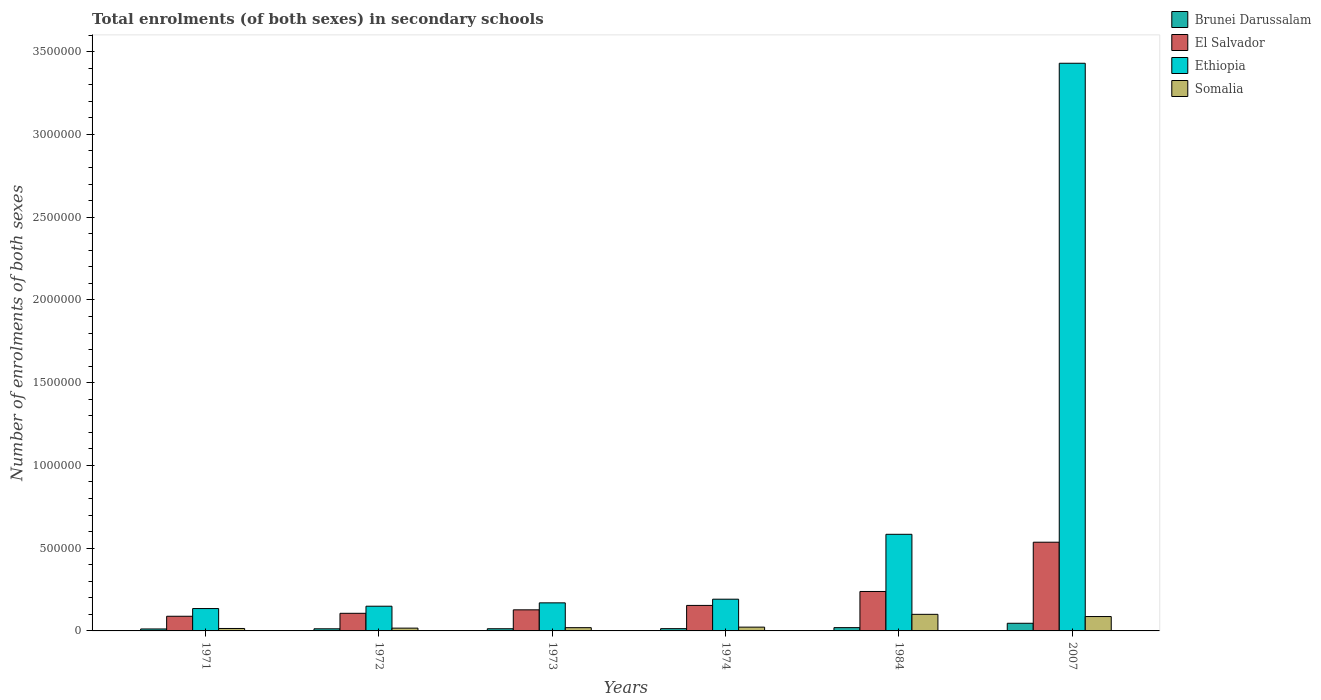How many different coloured bars are there?
Your answer should be very brief. 4. How many groups of bars are there?
Your answer should be very brief. 6. Are the number of bars per tick equal to the number of legend labels?
Offer a very short reply. Yes. What is the label of the 1st group of bars from the left?
Keep it short and to the point. 1971. In how many cases, is the number of bars for a given year not equal to the number of legend labels?
Offer a terse response. 0. What is the number of enrolments in secondary schools in Somalia in 1973?
Keep it short and to the point. 1.96e+04. Across all years, what is the maximum number of enrolments in secondary schools in Ethiopia?
Ensure brevity in your answer.  3.43e+06. Across all years, what is the minimum number of enrolments in secondary schools in El Salvador?
Offer a very short reply. 8.86e+04. What is the total number of enrolments in secondary schools in Ethiopia in the graph?
Ensure brevity in your answer.  4.66e+06. What is the difference between the number of enrolments in secondary schools in Somalia in 1971 and that in 1974?
Offer a very short reply. -8137. What is the difference between the number of enrolments in secondary schools in El Salvador in 2007 and the number of enrolments in secondary schools in Ethiopia in 1973?
Your response must be concise. 3.66e+05. What is the average number of enrolments in secondary schools in Somalia per year?
Keep it short and to the point. 4.35e+04. In the year 2007, what is the difference between the number of enrolments in secondary schools in Ethiopia and number of enrolments in secondary schools in Somalia?
Give a very brief answer. 3.34e+06. What is the ratio of the number of enrolments in secondary schools in El Salvador in 1973 to that in 2007?
Provide a short and direct response. 0.24. What is the difference between the highest and the second highest number of enrolments in secondary schools in El Salvador?
Your response must be concise. 2.98e+05. What is the difference between the highest and the lowest number of enrolments in secondary schools in El Salvador?
Offer a terse response. 4.47e+05. In how many years, is the number of enrolments in secondary schools in El Salvador greater than the average number of enrolments in secondary schools in El Salvador taken over all years?
Ensure brevity in your answer.  2. Is the sum of the number of enrolments in secondary schools in Brunei Darussalam in 1984 and 2007 greater than the maximum number of enrolments in secondary schools in El Salvador across all years?
Your answer should be compact. No. Is it the case that in every year, the sum of the number of enrolments in secondary schools in Ethiopia and number of enrolments in secondary schools in Brunei Darussalam is greater than the sum of number of enrolments in secondary schools in El Salvador and number of enrolments in secondary schools in Somalia?
Your answer should be compact. No. What does the 3rd bar from the left in 1971 represents?
Provide a succinct answer. Ethiopia. What does the 3rd bar from the right in 1971 represents?
Keep it short and to the point. El Salvador. How many bars are there?
Offer a very short reply. 24. How many years are there in the graph?
Ensure brevity in your answer.  6. What is the difference between two consecutive major ticks on the Y-axis?
Make the answer very short. 5.00e+05. Does the graph contain any zero values?
Give a very brief answer. No. Does the graph contain grids?
Your answer should be very brief. No. Where does the legend appear in the graph?
Provide a succinct answer. Top right. What is the title of the graph?
Your answer should be compact. Total enrolments (of both sexes) in secondary schools. Does "Paraguay" appear as one of the legend labels in the graph?
Make the answer very short. No. What is the label or title of the X-axis?
Provide a short and direct response. Years. What is the label or title of the Y-axis?
Make the answer very short. Number of enrolments of both sexes. What is the Number of enrolments of both sexes in Brunei Darussalam in 1971?
Ensure brevity in your answer.  1.18e+04. What is the Number of enrolments of both sexes of El Salvador in 1971?
Offer a very short reply. 8.86e+04. What is the Number of enrolments of both sexes in Ethiopia in 1971?
Provide a short and direct response. 1.35e+05. What is the Number of enrolments of both sexes in Somalia in 1971?
Provide a short and direct response. 1.48e+04. What is the Number of enrolments of both sexes of Brunei Darussalam in 1972?
Provide a short and direct response. 1.28e+04. What is the Number of enrolments of both sexes of El Salvador in 1972?
Your answer should be compact. 1.06e+05. What is the Number of enrolments of both sexes of Ethiopia in 1972?
Your response must be concise. 1.49e+05. What is the Number of enrolments of both sexes of Somalia in 1972?
Provide a short and direct response. 1.69e+04. What is the Number of enrolments of both sexes in Brunei Darussalam in 1973?
Ensure brevity in your answer.  1.31e+04. What is the Number of enrolments of both sexes of El Salvador in 1973?
Your response must be concise. 1.27e+05. What is the Number of enrolments of both sexes of Ethiopia in 1973?
Offer a terse response. 1.70e+05. What is the Number of enrolments of both sexes of Somalia in 1973?
Give a very brief answer. 1.96e+04. What is the Number of enrolments of both sexes of Brunei Darussalam in 1974?
Your answer should be very brief. 1.37e+04. What is the Number of enrolments of both sexes in El Salvador in 1974?
Your answer should be very brief. 1.54e+05. What is the Number of enrolments of both sexes of Ethiopia in 1974?
Give a very brief answer. 1.92e+05. What is the Number of enrolments of both sexes in Somalia in 1974?
Offer a terse response. 2.29e+04. What is the Number of enrolments of both sexes of Brunei Darussalam in 1984?
Keep it short and to the point. 1.99e+04. What is the Number of enrolments of both sexes in El Salvador in 1984?
Your answer should be very brief. 2.38e+05. What is the Number of enrolments of both sexes in Ethiopia in 1984?
Offer a very short reply. 5.84e+05. What is the Number of enrolments of both sexes of Somalia in 1984?
Give a very brief answer. 1.00e+05. What is the Number of enrolments of both sexes of Brunei Darussalam in 2007?
Keep it short and to the point. 4.62e+04. What is the Number of enrolments of both sexes of El Salvador in 2007?
Your answer should be compact. 5.36e+05. What is the Number of enrolments of both sexes in Ethiopia in 2007?
Your answer should be compact. 3.43e+06. What is the Number of enrolments of both sexes of Somalia in 2007?
Give a very brief answer. 8.69e+04. Across all years, what is the maximum Number of enrolments of both sexes in Brunei Darussalam?
Make the answer very short. 4.62e+04. Across all years, what is the maximum Number of enrolments of both sexes in El Salvador?
Make the answer very short. 5.36e+05. Across all years, what is the maximum Number of enrolments of both sexes of Ethiopia?
Provide a short and direct response. 3.43e+06. Across all years, what is the maximum Number of enrolments of both sexes in Somalia?
Ensure brevity in your answer.  1.00e+05. Across all years, what is the minimum Number of enrolments of both sexes of Brunei Darussalam?
Your answer should be compact. 1.18e+04. Across all years, what is the minimum Number of enrolments of both sexes in El Salvador?
Provide a short and direct response. 8.86e+04. Across all years, what is the minimum Number of enrolments of both sexes of Ethiopia?
Keep it short and to the point. 1.35e+05. Across all years, what is the minimum Number of enrolments of both sexes of Somalia?
Provide a succinct answer. 1.48e+04. What is the total Number of enrolments of both sexes of Brunei Darussalam in the graph?
Offer a terse response. 1.17e+05. What is the total Number of enrolments of both sexes in El Salvador in the graph?
Make the answer very short. 1.25e+06. What is the total Number of enrolments of both sexes in Ethiopia in the graph?
Keep it short and to the point. 4.66e+06. What is the total Number of enrolments of both sexes in Somalia in the graph?
Your response must be concise. 2.61e+05. What is the difference between the Number of enrolments of both sexes in Brunei Darussalam in 1971 and that in 1972?
Make the answer very short. -964. What is the difference between the Number of enrolments of both sexes of El Salvador in 1971 and that in 1972?
Keep it short and to the point. -1.78e+04. What is the difference between the Number of enrolments of both sexes in Ethiopia in 1971 and that in 1972?
Your answer should be very brief. -1.41e+04. What is the difference between the Number of enrolments of both sexes in Somalia in 1971 and that in 1972?
Make the answer very short. -2097. What is the difference between the Number of enrolments of both sexes in Brunei Darussalam in 1971 and that in 1973?
Your answer should be very brief. -1344. What is the difference between the Number of enrolments of both sexes of El Salvador in 1971 and that in 1973?
Your response must be concise. -3.87e+04. What is the difference between the Number of enrolments of both sexes in Ethiopia in 1971 and that in 1973?
Provide a short and direct response. -3.45e+04. What is the difference between the Number of enrolments of both sexes in Somalia in 1971 and that in 1973?
Keep it short and to the point. -4879. What is the difference between the Number of enrolments of both sexes of Brunei Darussalam in 1971 and that in 1974?
Provide a short and direct response. -1903. What is the difference between the Number of enrolments of both sexes in El Salvador in 1971 and that in 1974?
Keep it short and to the point. -6.55e+04. What is the difference between the Number of enrolments of both sexes of Ethiopia in 1971 and that in 1974?
Give a very brief answer. -5.65e+04. What is the difference between the Number of enrolments of both sexes in Somalia in 1971 and that in 1974?
Your answer should be compact. -8137. What is the difference between the Number of enrolments of both sexes of Brunei Darussalam in 1971 and that in 1984?
Give a very brief answer. -8103. What is the difference between the Number of enrolments of both sexes of El Salvador in 1971 and that in 1984?
Offer a terse response. -1.50e+05. What is the difference between the Number of enrolments of both sexes of Ethiopia in 1971 and that in 1984?
Provide a succinct answer. -4.49e+05. What is the difference between the Number of enrolments of both sexes in Somalia in 1971 and that in 1984?
Give a very brief answer. -8.54e+04. What is the difference between the Number of enrolments of both sexes in Brunei Darussalam in 1971 and that in 2007?
Your answer should be compact. -3.44e+04. What is the difference between the Number of enrolments of both sexes in El Salvador in 1971 and that in 2007?
Your response must be concise. -4.47e+05. What is the difference between the Number of enrolments of both sexes of Ethiopia in 1971 and that in 2007?
Ensure brevity in your answer.  -3.29e+06. What is the difference between the Number of enrolments of both sexes in Somalia in 1971 and that in 2007?
Provide a succinct answer. -7.22e+04. What is the difference between the Number of enrolments of both sexes of Brunei Darussalam in 1972 and that in 1973?
Your response must be concise. -380. What is the difference between the Number of enrolments of both sexes in El Salvador in 1972 and that in 1973?
Your response must be concise. -2.09e+04. What is the difference between the Number of enrolments of both sexes of Ethiopia in 1972 and that in 1973?
Provide a short and direct response. -2.03e+04. What is the difference between the Number of enrolments of both sexes in Somalia in 1972 and that in 1973?
Ensure brevity in your answer.  -2782. What is the difference between the Number of enrolments of both sexes of Brunei Darussalam in 1972 and that in 1974?
Your response must be concise. -939. What is the difference between the Number of enrolments of both sexes in El Salvador in 1972 and that in 1974?
Keep it short and to the point. -4.77e+04. What is the difference between the Number of enrolments of both sexes of Ethiopia in 1972 and that in 1974?
Make the answer very short. -4.24e+04. What is the difference between the Number of enrolments of both sexes in Somalia in 1972 and that in 1974?
Ensure brevity in your answer.  -6040. What is the difference between the Number of enrolments of both sexes in Brunei Darussalam in 1972 and that in 1984?
Offer a terse response. -7139. What is the difference between the Number of enrolments of both sexes in El Salvador in 1972 and that in 1984?
Your response must be concise. -1.32e+05. What is the difference between the Number of enrolments of both sexes of Ethiopia in 1972 and that in 1984?
Offer a very short reply. -4.34e+05. What is the difference between the Number of enrolments of both sexes in Somalia in 1972 and that in 1984?
Provide a succinct answer. -8.33e+04. What is the difference between the Number of enrolments of both sexes in Brunei Darussalam in 1972 and that in 2007?
Ensure brevity in your answer.  -3.34e+04. What is the difference between the Number of enrolments of both sexes in El Salvador in 1972 and that in 2007?
Provide a succinct answer. -4.30e+05. What is the difference between the Number of enrolments of both sexes in Ethiopia in 1972 and that in 2007?
Offer a very short reply. -3.28e+06. What is the difference between the Number of enrolments of both sexes of Somalia in 1972 and that in 2007?
Provide a succinct answer. -7.01e+04. What is the difference between the Number of enrolments of both sexes in Brunei Darussalam in 1973 and that in 1974?
Give a very brief answer. -559. What is the difference between the Number of enrolments of both sexes in El Salvador in 1973 and that in 1974?
Your answer should be compact. -2.68e+04. What is the difference between the Number of enrolments of both sexes in Ethiopia in 1973 and that in 1974?
Make the answer very short. -2.21e+04. What is the difference between the Number of enrolments of both sexes in Somalia in 1973 and that in 1974?
Offer a terse response. -3258. What is the difference between the Number of enrolments of both sexes of Brunei Darussalam in 1973 and that in 1984?
Keep it short and to the point. -6759. What is the difference between the Number of enrolments of both sexes of El Salvador in 1973 and that in 1984?
Make the answer very short. -1.11e+05. What is the difference between the Number of enrolments of both sexes in Ethiopia in 1973 and that in 1984?
Make the answer very short. -4.14e+05. What is the difference between the Number of enrolments of both sexes of Somalia in 1973 and that in 1984?
Offer a very short reply. -8.06e+04. What is the difference between the Number of enrolments of both sexes of Brunei Darussalam in 1973 and that in 2007?
Keep it short and to the point. -3.30e+04. What is the difference between the Number of enrolments of both sexes in El Salvador in 1973 and that in 2007?
Offer a terse response. -4.09e+05. What is the difference between the Number of enrolments of both sexes of Ethiopia in 1973 and that in 2007?
Your answer should be compact. -3.26e+06. What is the difference between the Number of enrolments of both sexes of Somalia in 1973 and that in 2007?
Keep it short and to the point. -6.73e+04. What is the difference between the Number of enrolments of both sexes of Brunei Darussalam in 1974 and that in 1984?
Your answer should be very brief. -6200. What is the difference between the Number of enrolments of both sexes in El Salvador in 1974 and that in 1984?
Offer a very short reply. -8.42e+04. What is the difference between the Number of enrolments of both sexes in Ethiopia in 1974 and that in 1984?
Provide a succinct answer. -3.92e+05. What is the difference between the Number of enrolments of both sexes of Somalia in 1974 and that in 1984?
Provide a succinct answer. -7.73e+04. What is the difference between the Number of enrolments of both sexes of Brunei Darussalam in 1974 and that in 2007?
Provide a short and direct response. -3.25e+04. What is the difference between the Number of enrolments of both sexes in El Salvador in 1974 and that in 2007?
Make the answer very short. -3.82e+05. What is the difference between the Number of enrolments of both sexes of Ethiopia in 1974 and that in 2007?
Your answer should be very brief. -3.24e+06. What is the difference between the Number of enrolments of both sexes of Somalia in 1974 and that in 2007?
Provide a short and direct response. -6.40e+04. What is the difference between the Number of enrolments of both sexes in Brunei Darussalam in 1984 and that in 2007?
Ensure brevity in your answer.  -2.63e+04. What is the difference between the Number of enrolments of both sexes of El Salvador in 1984 and that in 2007?
Keep it short and to the point. -2.98e+05. What is the difference between the Number of enrolments of both sexes in Ethiopia in 1984 and that in 2007?
Give a very brief answer. -2.85e+06. What is the difference between the Number of enrolments of both sexes of Somalia in 1984 and that in 2007?
Keep it short and to the point. 1.33e+04. What is the difference between the Number of enrolments of both sexes of Brunei Darussalam in 1971 and the Number of enrolments of both sexes of El Salvador in 1972?
Offer a very short reply. -9.47e+04. What is the difference between the Number of enrolments of both sexes of Brunei Darussalam in 1971 and the Number of enrolments of both sexes of Ethiopia in 1972?
Provide a succinct answer. -1.38e+05. What is the difference between the Number of enrolments of both sexes in Brunei Darussalam in 1971 and the Number of enrolments of both sexes in Somalia in 1972?
Make the answer very short. -5055. What is the difference between the Number of enrolments of both sexes in El Salvador in 1971 and the Number of enrolments of both sexes in Ethiopia in 1972?
Provide a succinct answer. -6.07e+04. What is the difference between the Number of enrolments of both sexes in El Salvador in 1971 and the Number of enrolments of both sexes in Somalia in 1972?
Offer a very short reply. 7.18e+04. What is the difference between the Number of enrolments of both sexes in Ethiopia in 1971 and the Number of enrolments of both sexes in Somalia in 1972?
Provide a short and direct response. 1.18e+05. What is the difference between the Number of enrolments of both sexes in Brunei Darussalam in 1971 and the Number of enrolments of both sexes in El Salvador in 1973?
Ensure brevity in your answer.  -1.16e+05. What is the difference between the Number of enrolments of both sexes of Brunei Darussalam in 1971 and the Number of enrolments of both sexes of Ethiopia in 1973?
Give a very brief answer. -1.58e+05. What is the difference between the Number of enrolments of both sexes of Brunei Darussalam in 1971 and the Number of enrolments of both sexes of Somalia in 1973?
Ensure brevity in your answer.  -7837. What is the difference between the Number of enrolments of both sexes in El Salvador in 1971 and the Number of enrolments of both sexes in Ethiopia in 1973?
Keep it short and to the point. -8.10e+04. What is the difference between the Number of enrolments of both sexes of El Salvador in 1971 and the Number of enrolments of both sexes of Somalia in 1973?
Make the answer very short. 6.90e+04. What is the difference between the Number of enrolments of both sexes of Ethiopia in 1971 and the Number of enrolments of both sexes of Somalia in 1973?
Make the answer very short. 1.16e+05. What is the difference between the Number of enrolments of both sexes of Brunei Darussalam in 1971 and the Number of enrolments of both sexes of El Salvador in 1974?
Give a very brief answer. -1.42e+05. What is the difference between the Number of enrolments of both sexes of Brunei Darussalam in 1971 and the Number of enrolments of both sexes of Ethiopia in 1974?
Ensure brevity in your answer.  -1.80e+05. What is the difference between the Number of enrolments of both sexes of Brunei Darussalam in 1971 and the Number of enrolments of both sexes of Somalia in 1974?
Your response must be concise. -1.11e+04. What is the difference between the Number of enrolments of both sexes in El Salvador in 1971 and the Number of enrolments of both sexes in Ethiopia in 1974?
Provide a short and direct response. -1.03e+05. What is the difference between the Number of enrolments of both sexes in El Salvador in 1971 and the Number of enrolments of both sexes in Somalia in 1974?
Make the answer very short. 6.57e+04. What is the difference between the Number of enrolments of both sexes in Ethiopia in 1971 and the Number of enrolments of both sexes in Somalia in 1974?
Offer a very short reply. 1.12e+05. What is the difference between the Number of enrolments of both sexes of Brunei Darussalam in 1971 and the Number of enrolments of both sexes of El Salvador in 1984?
Your answer should be compact. -2.27e+05. What is the difference between the Number of enrolments of both sexes in Brunei Darussalam in 1971 and the Number of enrolments of both sexes in Ethiopia in 1984?
Ensure brevity in your answer.  -5.72e+05. What is the difference between the Number of enrolments of both sexes of Brunei Darussalam in 1971 and the Number of enrolments of both sexes of Somalia in 1984?
Keep it short and to the point. -8.84e+04. What is the difference between the Number of enrolments of both sexes of El Salvador in 1971 and the Number of enrolments of both sexes of Ethiopia in 1984?
Your answer should be very brief. -4.95e+05. What is the difference between the Number of enrolments of both sexes of El Salvador in 1971 and the Number of enrolments of both sexes of Somalia in 1984?
Make the answer very short. -1.16e+04. What is the difference between the Number of enrolments of both sexes of Ethiopia in 1971 and the Number of enrolments of both sexes of Somalia in 1984?
Provide a short and direct response. 3.50e+04. What is the difference between the Number of enrolments of both sexes of Brunei Darussalam in 1971 and the Number of enrolments of both sexes of El Salvador in 2007?
Keep it short and to the point. -5.24e+05. What is the difference between the Number of enrolments of both sexes in Brunei Darussalam in 1971 and the Number of enrolments of both sexes in Ethiopia in 2007?
Make the answer very short. -3.42e+06. What is the difference between the Number of enrolments of both sexes in Brunei Darussalam in 1971 and the Number of enrolments of both sexes in Somalia in 2007?
Your answer should be compact. -7.51e+04. What is the difference between the Number of enrolments of both sexes in El Salvador in 1971 and the Number of enrolments of both sexes in Ethiopia in 2007?
Provide a short and direct response. -3.34e+06. What is the difference between the Number of enrolments of both sexes of El Salvador in 1971 and the Number of enrolments of both sexes of Somalia in 2007?
Give a very brief answer. 1706. What is the difference between the Number of enrolments of both sexes in Ethiopia in 1971 and the Number of enrolments of both sexes in Somalia in 2007?
Ensure brevity in your answer.  4.82e+04. What is the difference between the Number of enrolments of both sexes in Brunei Darussalam in 1972 and the Number of enrolments of both sexes in El Salvador in 1973?
Your answer should be compact. -1.15e+05. What is the difference between the Number of enrolments of both sexes of Brunei Darussalam in 1972 and the Number of enrolments of both sexes of Ethiopia in 1973?
Offer a terse response. -1.57e+05. What is the difference between the Number of enrolments of both sexes in Brunei Darussalam in 1972 and the Number of enrolments of both sexes in Somalia in 1973?
Ensure brevity in your answer.  -6873. What is the difference between the Number of enrolments of both sexes of El Salvador in 1972 and the Number of enrolments of both sexes of Ethiopia in 1973?
Offer a terse response. -6.32e+04. What is the difference between the Number of enrolments of both sexes of El Salvador in 1972 and the Number of enrolments of both sexes of Somalia in 1973?
Provide a short and direct response. 8.68e+04. What is the difference between the Number of enrolments of both sexes in Ethiopia in 1972 and the Number of enrolments of both sexes in Somalia in 1973?
Your answer should be very brief. 1.30e+05. What is the difference between the Number of enrolments of both sexes in Brunei Darussalam in 1972 and the Number of enrolments of both sexes in El Salvador in 1974?
Your answer should be very brief. -1.41e+05. What is the difference between the Number of enrolments of both sexes of Brunei Darussalam in 1972 and the Number of enrolments of both sexes of Ethiopia in 1974?
Give a very brief answer. -1.79e+05. What is the difference between the Number of enrolments of both sexes of Brunei Darussalam in 1972 and the Number of enrolments of both sexes of Somalia in 1974?
Offer a terse response. -1.01e+04. What is the difference between the Number of enrolments of both sexes in El Salvador in 1972 and the Number of enrolments of both sexes in Ethiopia in 1974?
Your answer should be very brief. -8.52e+04. What is the difference between the Number of enrolments of both sexes in El Salvador in 1972 and the Number of enrolments of both sexes in Somalia in 1974?
Keep it short and to the point. 8.36e+04. What is the difference between the Number of enrolments of both sexes of Ethiopia in 1972 and the Number of enrolments of both sexes of Somalia in 1974?
Keep it short and to the point. 1.26e+05. What is the difference between the Number of enrolments of both sexes in Brunei Darussalam in 1972 and the Number of enrolments of both sexes in El Salvador in 1984?
Your answer should be very brief. -2.26e+05. What is the difference between the Number of enrolments of both sexes of Brunei Darussalam in 1972 and the Number of enrolments of both sexes of Ethiopia in 1984?
Your answer should be very brief. -5.71e+05. What is the difference between the Number of enrolments of both sexes of Brunei Darussalam in 1972 and the Number of enrolments of both sexes of Somalia in 1984?
Provide a short and direct response. -8.74e+04. What is the difference between the Number of enrolments of both sexes in El Salvador in 1972 and the Number of enrolments of both sexes in Ethiopia in 1984?
Your answer should be very brief. -4.77e+05. What is the difference between the Number of enrolments of both sexes of El Salvador in 1972 and the Number of enrolments of both sexes of Somalia in 1984?
Give a very brief answer. 6266. What is the difference between the Number of enrolments of both sexes in Ethiopia in 1972 and the Number of enrolments of both sexes in Somalia in 1984?
Provide a succinct answer. 4.91e+04. What is the difference between the Number of enrolments of both sexes of Brunei Darussalam in 1972 and the Number of enrolments of both sexes of El Salvador in 2007?
Ensure brevity in your answer.  -5.23e+05. What is the difference between the Number of enrolments of both sexes of Brunei Darussalam in 1972 and the Number of enrolments of both sexes of Ethiopia in 2007?
Ensure brevity in your answer.  -3.42e+06. What is the difference between the Number of enrolments of both sexes of Brunei Darussalam in 1972 and the Number of enrolments of both sexes of Somalia in 2007?
Your answer should be compact. -7.42e+04. What is the difference between the Number of enrolments of both sexes of El Salvador in 1972 and the Number of enrolments of both sexes of Ethiopia in 2007?
Ensure brevity in your answer.  -3.32e+06. What is the difference between the Number of enrolments of both sexes in El Salvador in 1972 and the Number of enrolments of both sexes in Somalia in 2007?
Your answer should be very brief. 1.95e+04. What is the difference between the Number of enrolments of both sexes of Ethiopia in 1972 and the Number of enrolments of both sexes of Somalia in 2007?
Keep it short and to the point. 6.24e+04. What is the difference between the Number of enrolments of both sexes in Brunei Darussalam in 1973 and the Number of enrolments of both sexes in El Salvador in 1974?
Your answer should be compact. -1.41e+05. What is the difference between the Number of enrolments of both sexes in Brunei Darussalam in 1973 and the Number of enrolments of both sexes in Ethiopia in 1974?
Give a very brief answer. -1.79e+05. What is the difference between the Number of enrolments of both sexes in Brunei Darussalam in 1973 and the Number of enrolments of both sexes in Somalia in 1974?
Make the answer very short. -9751. What is the difference between the Number of enrolments of both sexes of El Salvador in 1973 and the Number of enrolments of both sexes of Ethiopia in 1974?
Make the answer very short. -6.43e+04. What is the difference between the Number of enrolments of both sexes of El Salvador in 1973 and the Number of enrolments of both sexes of Somalia in 1974?
Provide a succinct answer. 1.04e+05. What is the difference between the Number of enrolments of both sexes of Ethiopia in 1973 and the Number of enrolments of both sexes of Somalia in 1974?
Provide a succinct answer. 1.47e+05. What is the difference between the Number of enrolments of both sexes in Brunei Darussalam in 1973 and the Number of enrolments of both sexes in El Salvador in 1984?
Your response must be concise. -2.25e+05. What is the difference between the Number of enrolments of both sexes in Brunei Darussalam in 1973 and the Number of enrolments of both sexes in Ethiopia in 1984?
Give a very brief answer. -5.71e+05. What is the difference between the Number of enrolments of both sexes of Brunei Darussalam in 1973 and the Number of enrolments of both sexes of Somalia in 1984?
Your answer should be very brief. -8.71e+04. What is the difference between the Number of enrolments of both sexes in El Salvador in 1973 and the Number of enrolments of both sexes in Ethiopia in 1984?
Provide a short and direct response. -4.56e+05. What is the difference between the Number of enrolments of both sexes of El Salvador in 1973 and the Number of enrolments of both sexes of Somalia in 1984?
Make the answer very short. 2.72e+04. What is the difference between the Number of enrolments of both sexes in Ethiopia in 1973 and the Number of enrolments of both sexes in Somalia in 1984?
Your answer should be compact. 6.94e+04. What is the difference between the Number of enrolments of both sexes of Brunei Darussalam in 1973 and the Number of enrolments of both sexes of El Salvador in 2007?
Give a very brief answer. -5.23e+05. What is the difference between the Number of enrolments of both sexes in Brunei Darussalam in 1973 and the Number of enrolments of both sexes in Ethiopia in 2007?
Provide a short and direct response. -3.42e+06. What is the difference between the Number of enrolments of both sexes of Brunei Darussalam in 1973 and the Number of enrolments of both sexes of Somalia in 2007?
Offer a terse response. -7.38e+04. What is the difference between the Number of enrolments of both sexes in El Salvador in 1973 and the Number of enrolments of both sexes in Ethiopia in 2007?
Your answer should be compact. -3.30e+06. What is the difference between the Number of enrolments of both sexes of El Salvador in 1973 and the Number of enrolments of both sexes of Somalia in 2007?
Your answer should be very brief. 4.05e+04. What is the difference between the Number of enrolments of both sexes of Ethiopia in 1973 and the Number of enrolments of both sexes of Somalia in 2007?
Provide a short and direct response. 8.27e+04. What is the difference between the Number of enrolments of both sexes of Brunei Darussalam in 1974 and the Number of enrolments of both sexes of El Salvador in 1984?
Give a very brief answer. -2.25e+05. What is the difference between the Number of enrolments of both sexes in Brunei Darussalam in 1974 and the Number of enrolments of both sexes in Ethiopia in 1984?
Make the answer very short. -5.70e+05. What is the difference between the Number of enrolments of both sexes in Brunei Darussalam in 1974 and the Number of enrolments of both sexes in Somalia in 1984?
Your response must be concise. -8.65e+04. What is the difference between the Number of enrolments of both sexes of El Salvador in 1974 and the Number of enrolments of both sexes of Ethiopia in 1984?
Your answer should be compact. -4.30e+05. What is the difference between the Number of enrolments of both sexes of El Salvador in 1974 and the Number of enrolments of both sexes of Somalia in 1984?
Make the answer very short. 5.39e+04. What is the difference between the Number of enrolments of both sexes of Ethiopia in 1974 and the Number of enrolments of both sexes of Somalia in 1984?
Provide a short and direct response. 9.15e+04. What is the difference between the Number of enrolments of both sexes of Brunei Darussalam in 1974 and the Number of enrolments of both sexes of El Salvador in 2007?
Provide a succinct answer. -5.22e+05. What is the difference between the Number of enrolments of both sexes in Brunei Darussalam in 1974 and the Number of enrolments of both sexes in Ethiopia in 2007?
Offer a very short reply. -3.42e+06. What is the difference between the Number of enrolments of both sexes of Brunei Darussalam in 1974 and the Number of enrolments of both sexes of Somalia in 2007?
Your answer should be very brief. -7.32e+04. What is the difference between the Number of enrolments of both sexes in El Salvador in 1974 and the Number of enrolments of both sexes in Ethiopia in 2007?
Offer a very short reply. -3.28e+06. What is the difference between the Number of enrolments of both sexes of El Salvador in 1974 and the Number of enrolments of both sexes of Somalia in 2007?
Ensure brevity in your answer.  6.72e+04. What is the difference between the Number of enrolments of both sexes of Ethiopia in 1974 and the Number of enrolments of both sexes of Somalia in 2007?
Your response must be concise. 1.05e+05. What is the difference between the Number of enrolments of both sexes in Brunei Darussalam in 1984 and the Number of enrolments of both sexes in El Salvador in 2007?
Offer a very short reply. -5.16e+05. What is the difference between the Number of enrolments of both sexes of Brunei Darussalam in 1984 and the Number of enrolments of both sexes of Ethiopia in 2007?
Your answer should be compact. -3.41e+06. What is the difference between the Number of enrolments of both sexes in Brunei Darussalam in 1984 and the Number of enrolments of both sexes in Somalia in 2007?
Give a very brief answer. -6.70e+04. What is the difference between the Number of enrolments of both sexes of El Salvador in 1984 and the Number of enrolments of both sexes of Ethiopia in 2007?
Provide a succinct answer. -3.19e+06. What is the difference between the Number of enrolments of both sexes of El Salvador in 1984 and the Number of enrolments of both sexes of Somalia in 2007?
Provide a succinct answer. 1.51e+05. What is the difference between the Number of enrolments of both sexes of Ethiopia in 1984 and the Number of enrolments of both sexes of Somalia in 2007?
Keep it short and to the point. 4.97e+05. What is the average Number of enrolments of both sexes in Brunei Darussalam per year?
Offer a very short reply. 1.96e+04. What is the average Number of enrolments of both sexes of El Salvador per year?
Ensure brevity in your answer.  2.08e+05. What is the average Number of enrolments of both sexes in Ethiopia per year?
Give a very brief answer. 7.77e+05. What is the average Number of enrolments of both sexes in Somalia per year?
Keep it short and to the point. 4.35e+04. In the year 1971, what is the difference between the Number of enrolments of both sexes in Brunei Darussalam and Number of enrolments of both sexes in El Salvador?
Ensure brevity in your answer.  -7.68e+04. In the year 1971, what is the difference between the Number of enrolments of both sexes of Brunei Darussalam and Number of enrolments of both sexes of Ethiopia?
Your answer should be compact. -1.23e+05. In the year 1971, what is the difference between the Number of enrolments of both sexes in Brunei Darussalam and Number of enrolments of both sexes in Somalia?
Offer a very short reply. -2958. In the year 1971, what is the difference between the Number of enrolments of both sexes of El Salvador and Number of enrolments of both sexes of Ethiopia?
Keep it short and to the point. -4.65e+04. In the year 1971, what is the difference between the Number of enrolments of both sexes in El Salvador and Number of enrolments of both sexes in Somalia?
Make the answer very short. 7.39e+04. In the year 1971, what is the difference between the Number of enrolments of both sexes in Ethiopia and Number of enrolments of both sexes in Somalia?
Provide a succinct answer. 1.20e+05. In the year 1972, what is the difference between the Number of enrolments of both sexes in Brunei Darussalam and Number of enrolments of both sexes in El Salvador?
Your answer should be compact. -9.37e+04. In the year 1972, what is the difference between the Number of enrolments of both sexes of Brunei Darussalam and Number of enrolments of both sexes of Ethiopia?
Offer a terse response. -1.37e+05. In the year 1972, what is the difference between the Number of enrolments of both sexes in Brunei Darussalam and Number of enrolments of both sexes in Somalia?
Keep it short and to the point. -4091. In the year 1972, what is the difference between the Number of enrolments of both sexes in El Salvador and Number of enrolments of both sexes in Ethiopia?
Provide a short and direct response. -4.28e+04. In the year 1972, what is the difference between the Number of enrolments of both sexes in El Salvador and Number of enrolments of both sexes in Somalia?
Offer a very short reply. 8.96e+04. In the year 1972, what is the difference between the Number of enrolments of both sexes of Ethiopia and Number of enrolments of both sexes of Somalia?
Your answer should be compact. 1.32e+05. In the year 1973, what is the difference between the Number of enrolments of both sexes in Brunei Darussalam and Number of enrolments of both sexes in El Salvador?
Your response must be concise. -1.14e+05. In the year 1973, what is the difference between the Number of enrolments of both sexes in Brunei Darussalam and Number of enrolments of both sexes in Ethiopia?
Offer a very short reply. -1.56e+05. In the year 1973, what is the difference between the Number of enrolments of both sexes of Brunei Darussalam and Number of enrolments of both sexes of Somalia?
Your answer should be very brief. -6493. In the year 1973, what is the difference between the Number of enrolments of both sexes in El Salvador and Number of enrolments of both sexes in Ethiopia?
Offer a terse response. -4.23e+04. In the year 1973, what is the difference between the Number of enrolments of both sexes in El Salvador and Number of enrolments of both sexes in Somalia?
Provide a short and direct response. 1.08e+05. In the year 1973, what is the difference between the Number of enrolments of both sexes of Ethiopia and Number of enrolments of both sexes of Somalia?
Offer a terse response. 1.50e+05. In the year 1974, what is the difference between the Number of enrolments of both sexes of Brunei Darussalam and Number of enrolments of both sexes of El Salvador?
Your answer should be compact. -1.40e+05. In the year 1974, what is the difference between the Number of enrolments of both sexes in Brunei Darussalam and Number of enrolments of both sexes in Ethiopia?
Ensure brevity in your answer.  -1.78e+05. In the year 1974, what is the difference between the Number of enrolments of both sexes in Brunei Darussalam and Number of enrolments of both sexes in Somalia?
Provide a succinct answer. -9192. In the year 1974, what is the difference between the Number of enrolments of both sexes in El Salvador and Number of enrolments of both sexes in Ethiopia?
Your response must be concise. -3.76e+04. In the year 1974, what is the difference between the Number of enrolments of both sexes of El Salvador and Number of enrolments of both sexes of Somalia?
Ensure brevity in your answer.  1.31e+05. In the year 1974, what is the difference between the Number of enrolments of both sexes in Ethiopia and Number of enrolments of both sexes in Somalia?
Give a very brief answer. 1.69e+05. In the year 1984, what is the difference between the Number of enrolments of both sexes of Brunei Darussalam and Number of enrolments of both sexes of El Salvador?
Your answer should be compact. -2.18e+05. In the year 1984, what is the difference between the Number of enrolments of both sexes of Brunei Darussalam and Number of enrolments of both sexes of Ethiopia?
Give a very brief answer. -5.64e+05. In the year 1984, what is the difference between the Number of enrolments of both sexes of Brunei Darussalam and Number of enrolments of both sexes of Somalia?
Offer a terse response. -8.03e+04. In the year 1984, what is the difference between the Number of enrolments of both sexes in El Salvador and Number of enrolments of both sexes in Ethiopia?
Provide a short and direct response. -3.45e+05. In the year 1984, what is the difference between the Number of enrolments of both sexes in El Salvador and Number of enrolments of both sexes in Somalia?
Ensure brevity in your answer.  1.38e+05. In the year 1984, what is the difference between the Number of enrolments of both sexes of Ethiopia and Number of enrolments of both sexes of Somalia?
Keep it short and to the point. 4.84e+05. In the year 2007, what is the difference between the Number of enrolments of both sexes of Brunei Darussalam and Number of enrolments of both sexes of El Salvador?
Provide a short and direct response. -4.90e+05. In the year 2007, what is the difference between the Number of enrolments of both sexes of Brunei Darussalam and Number of enrolments of both sexes of Ethiopia?
Your answer should be compact. -3.38e+06. In the year 2007, what is the difference between the Number of enrolments of both sexes in Brunei Darussalam and Number of enrolments of both sexes in Somalia?
Your response must be concise. -4.08e+04. In the year 2007, what is the difference between the Number of enrolments of both sexes in El Salvador and Number of enrolments of both sexes in Ethiopia?
Provide a short and direct response. -2.89e+06. In the year 2007, what is the difference between the Number of enrolments of both sexes of El Salvador and Number of enrolments of both sexes of Somalia?
Give a very brief answer. 4.49e+05. In the year 2007, what is the difference between the Number of enrolments of both sexes of Ethiopia and Number of enrolments of both sexes of Somalia?
Provide a short and direct response. 3.34e+06. What is the ratio of the Number of enrolments of both sexes in Brunei Darussalam in 1971 to that in 1972?
Provide a succinct answer. 0.92. What is the ratio of the Number of enrolments of both sexes of El Salvador in 1971 to that in 1972?
Keep it short and to the point. 0.83. What is the ratio of the Number of enrolments of both sexes of Ethiopia in 1971 to that in 1972?
Make the answer very short. 0.91. What is the ratio of the Number of enrolments of both sexes of Somalia in 1971 to that in 1972?
Your response must be concise. 0.88. What is the ratio of the Number of enrolments of both sexes in Brunei Darussalam in 1971 to that in 1973?
Your answer should be very brief. 0.9. What is the ratio of the Number of enrolments of both sexes of El Salvador in 1971 to that in 1973?
Give a very brief answer. 0.7. What is the ratio of the Number of enrolments of both sexes in Ethiopia in 1971 to that in 1973?
Provide a short and direct response. 0.8. What is the ratio of the Number of enrolments of both sexes in Somalia in 1971 to that in 1973?
Offer a terse response. 0.75. What is the ratio of the Number of enrolments of both sexes in Brunei Darussalam in 1971 to that in 1974?
Offer a very short reply. 0.86. What is the ratio of the Number of enrolments of both sexes in El Salvador in 1971 to that in 1974?
Your answer should be compact. 0.57. What is the ratio of the Number of enrolments of both sexes of Ethiopia in 1971 to that in 1974?
Make the answer very short. 0.71. What is the ratio of the Number of enrolments of both sexes in Somalia in 1971 to that in 1974?
Provide a short and direct response. 0.64. What is the ratio of the Number of enrolments of both sexes of Brunei Darussalam in 1971 to that in 1984?
Offer a very short reply. 0.59. What is the ratio of the Number of enrolments of both sexes in El Salvador in 1971 to that in 1984?
Your answer should be very brief. 0.37. What is the ratio of the Number of enrolments of both sexes of Ethiopia in 1971 to that in 1984?
Provide a succinct answer. 0.23. What is the ratio of the Number of enrolments of both sexes in Somalia in 1971 to that in 1984?
Your response must be concise. 0.15. What is the ratio of the Number of enrolments of both sexes of Brunei Darussalam in 1971 to that in 2007?
Offer a terse response. 0.26. What is the ratio of the Number of enrolments of both sexes in El Salvador in 1971 to that in 2007?
Offer a terse response. 0.17. What is the ratio of the Number of enrolments of both sexes in Ethiopia in 1971 to that in 2007?
Give a very brief answer. 0.04. What is the ratio of the Number of enrolments of both sexes of Somalia in 1971 to that in 2007?
Give a very brief answer. 0.17. What is the ratio of the Number of enrolments of both sexes of Brunei Darussalam in 1972 to that in 1973?
Offer a very short reply. 0.97. What is the ratio of the Number of enrolments of both sexes in El Salvador in 1972 to that in 1973?
Provide a short and direct response. 0.84. What is the ratio of the Number of enrolments of both sexes of Ethiopia in 1972 to that in 1973?
Your answer should be very brief. 0.88. What is the ratio of the Number of enrolments of both sexes of Somalia in 1972 to that in 1973?
Your answer should be very brief. 0.86. What is the ratio of the Number of enrolments of both sexes of Brunei Darussalam in 1972 to that in 1974?
Offer a very short reply. 0.93. What is the ratio of the Number of enrolments of both sexes of El Salvador in 1972 to that in 1974?
Give a very brief answer. 0.69. What is the ratio of the Number of enrolments of both sexes in Ethiopia in 1972 to that in 1974?
Provide a short and direct response. 0.78. What is the ratio of the Number of enrolments of both sexes of Somalia in 1972 to that in 1974?
Offer a terse response. 0.74. What is the ratio of the Number of enrolments of both sexes of Brunei Darussalam in 1972 to that in 1984?
Your answer should be compact. 0.64. What is the ratio of the Number of enrolments of both sexes of El Salvador in 1972 to that in 1984?
Your answer should be compact. 0.45. What is the ratio of the Number of enrolments of both sexes of Ethiopia in 1972 to that in 1984?
Keep it short and to the point. 0.26. What is the ratio of the Number of enrolments of both sexes in Somalia in 1972 to that in 1984?
Make the answer very short. 0.17. What is the ratio of the Number of enrolments of both sexes of Brunei Darussalam in 1972 to that in 2007?
Provide a short and direct response. 0.28. What is the ratio of the Number of enrolments of both sexes of El Salvador in 1972 to that in 2007?
Ensure brevity in your answer.  0.2. What is the ratio of the Number of enrolments of both sexes in Ethiopia in 1972 to that in 2007?
Your response must be concise. 0.04. What is the ratio of the Number of enrolments of both sexes of Somalia in 1972 to that in 2007?
Give a very brief answer. 0.19. What is the ratio of the Number of enrolments of both sexes in Brunei Darussalam in 1973 to that in 1974?
Provide a succinct answer. 0.96. What is the ratio of the Number of enrolments of both sexes of El Salvador in 1973 to that in 1974?
Ensure brevity in your answer.  0.83. What is the ratio of the Number of enrolments of both sexes in Ethiopia in 1973 to that in 1974?
Your response must be concise. 0.88. What is the ratio of the Number of enrolments of both sexes in Somalia in 1973 to that in 1974?
Keep it short and to the point. 0.86. What is the ratio of the Number of enrolments of both sexes of Brunei Darussalam in 1973 to that in 1984?
Keep it short and to the point. 0.66. What is the ratio of the Number of enrolments of both sexes in El Salvador in 1973 to that in 1984?
Give a very brief answer. 0.53. What is the ratio of the Number of enrolments of both sexes of Ethiopia in 1973 to that in 1984?
Provide a short and direct response. 0.29. What is the ratio of the Number of enrolments of both sexes in Somalia in 1973 to that in 1984?
Provide a short and direct response. 0.2. What is the ratio of the Number of enrolments of both sexes of Brunei Darussalam in 1973 to that in 2007?
Your answer should be very brief. 0.28. What is the ratio of the Number of enrolments of both sexes in El Salvador in 1973 to that in 2007?
Offer a terse response. 0.24. What is the ratio of the Number of enrolments of both sexes of Ethiopia in 1973 to that in 2007?
Provide a short and direct response. 0.05. What is the ratio of the Number of enrolments of both sexes in Somalia in 1973 to that in 2007?
Make the answer very short. 0.23. What is the ratio of the Number of enrolments of both sexes of Brunei Darussalam in 1974 to that in 1984?
Offer a terse response. 0.69. What is the ratio of the Number of enrolments of both sexes in El Salvador in 1974 to that in 1984?
Offer a very short reply. 0.65. What is the ratio of the Number of enrolments of both sexes of Ethiopia in 1974 to that in 1984?
Ensure brevity in your answer.  0.33. What is the ratio of the Number of enrolments of both sexes in Somalia in 1974 to that in 1984?
Offer a very short reply. 0.23. What is the ratio of the Number of enrolments of both sexes in Brunei Darussalam in 1974 to that in 2007?
Give a very brief answer. 0.3. What is the ratio of the Number of enrolments of both sexes of El Salvador in 1974 to that in 2007?
Make the answer very short. 0.29. What is the ratio of the Number of enrolments of both sexes in Ethiopia in 1974 to that in 2007?
Offer a terse response. 0.06. What is the ratio of the Number of enrolments of both sexes in Somalia in 1974 to that in 2007?
Keep it short and to the point. 0.26. What is the ratio of the Number of enrolments of both sexes of Brunei Darussalam in 1984 to that in 2007?
Give a very brief answer. 0.43. What is the ratio of the Number of enrolments of both sexes of El Salvador in 1984 to that in 2007?
Keep it short and to the point. 0.44. What is the ratio of the Number of enrolments of both sexes in Ethiopia in 1984 to that in 2007?
Provide a succinct answer. 0.17. What is the ratio of the Number of enrolments of both sexes in Somalia in 1984 to that in 2007?
Provide a succinct answer. 1.15. What is the difference between the highest and the second highest Number of enrolments of both sexes of Brunei Darussalam?
Your response must be concise. 2.63e+04. What is the difference between the highest and the second highest Number of enrolments of both sexes in El Salvador?
Your response must be concise. 2.98e+05. What is the difference between the highest and the second highest Number of enrolments of both sexes of Ethiopia?
Give a very brief answer. 2.85e+06. What is the difference between the highest and the second highest Number of enrolments of both sexes in Somalia?
Keep it short and to the point. 1.33e+04. What is the difference between the highest and the lowest Number of enrolments of both sexes in Brunei Darussalam?
Give a very brief answer. 3.44e+04. What is the difference between the highest and the lowest Number of enrolments of both sexes in El Salvador?
Give a very brief answer. 4.47e+05. What is the difference between the highest and the lowest Number of enrolments of both sexes in Ethiopia?
Give a very brief answer. 3.29e+06. What is the difference between the highest and the lowest Number of enrolments of both sexes in Somalia?
Offer a very short reply. 8.54e+04. 